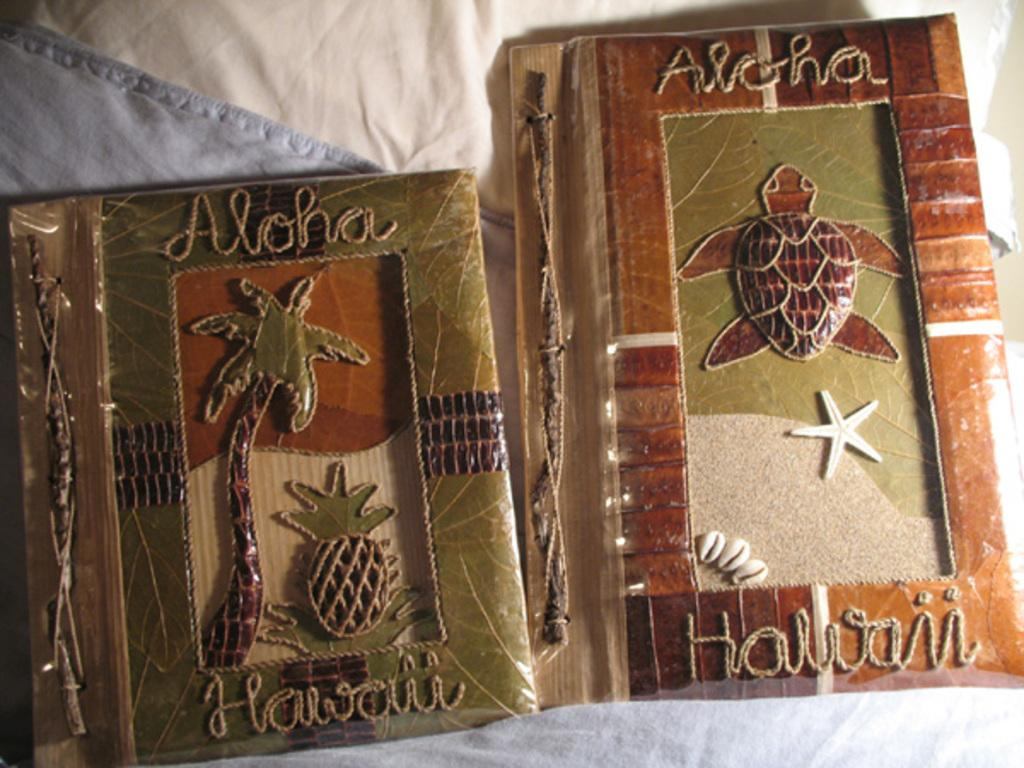<image>
Offer a succinct explanation of the picture presented. two Aloha Hawaii books on display some where 